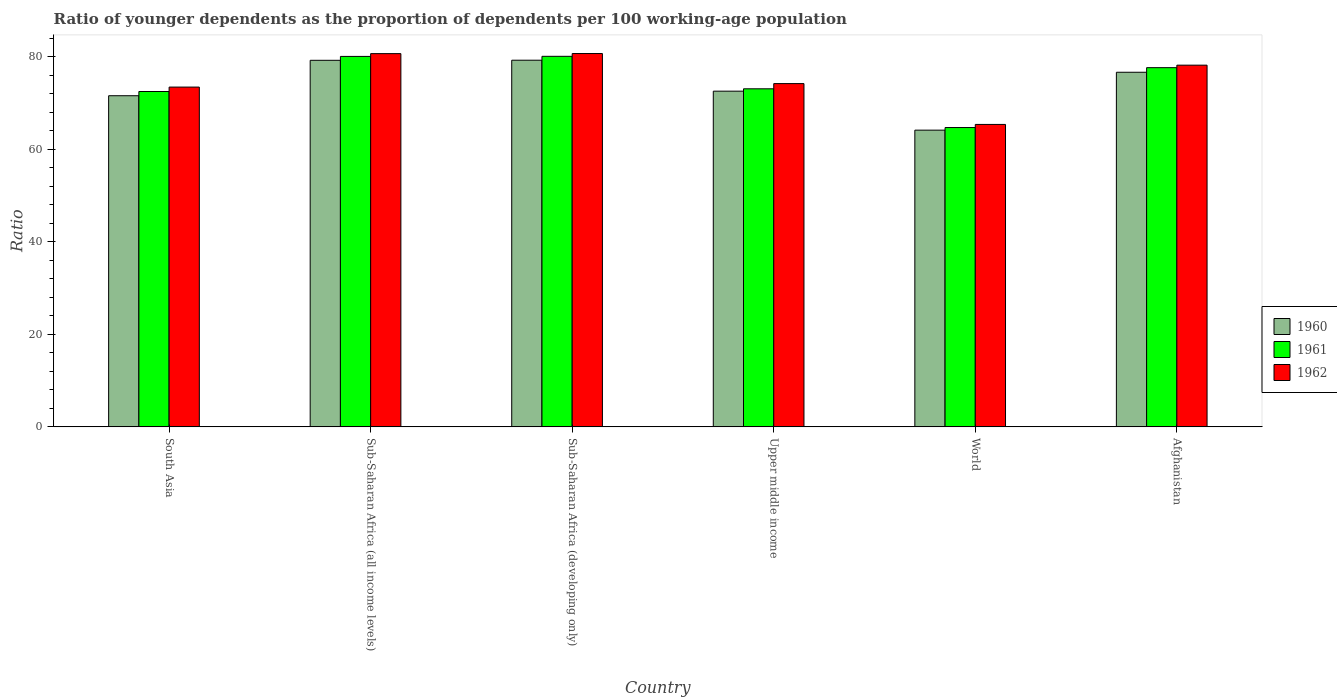How many different coloured bars are there?
Give a very brief answer. 3. Are the number of bars per tick equal to the number of legend labels?
Offer a terse response. Yes. How many bars are there on the 5th tick from the right?
Your answer should be very brief. 3. What is the age dependency ratio(young) in 1961 in Sub-Saharan Africa (all income levels)?
Your response must be concise. 80.06. Across all countries, what is the maximum age dependency ratio(young) in 1962?
Provide a succinct answer. 80.68. Across all countries, what is the minimum age dependency ratio(young) in 1962?
Your response must be concise. 65.36. In which country was the age dependency ratio(young) in 1962 maximum?
Keep it short and to the point. Sub-Saharan Africa (developing only). In which country was the age dependency ratio(young) in 1962 minimum?
Your answer should be compact. World. What is the total age dependency ratio(young) in 1961 in the graph?
Provide a short and direct response. 447.96. What is the difference between the age dependency ratio(young) in 1961 in Afghanistan and that in Upper middle income?
Ensure brevity in your answer.  4.57. What is the difference between the age dependency ratio(young) in 1961 in South Asia and the age dependency ratio(young) in 1962 in Sub-Saharan Africa (developing only)?
Make the answer very short. -8.21. What is the average age dependency ratio(young) in 1962 per country?
Offer a terse response. 75.41. What is the difference between the age dependency ratio(young) of/in 1961 and age dependency ratio(young) of/in 1960 in Upper middle income?
Keep it short and to the point. 0.51. In how many countries, is the age dependency ratio(young) in 1960 greater than 36?
Offer a terse response. 6. What is the ratio of the age dependency ratio(young) in 1961 in Afghanistan to that in Upper middle income?
Keep it short and to the point. 1.06. What is the difference between the highest and the second highest age dependency ratio(young) in 1960?
Give a very brief answer. -2.58. What is the difference between the highest and the lowest age dependency ratio(young) in 1961?
Provide a short and direct response. 15.39. In how many countries, is the age dependency ratio(young) in 1960 greater than the average age dependency ratio(young) in 1960 taken over all countries?
Your response must be concise. 3. Is the sum of the age dependency ratio(young) in 1962 in Sub-Saharan Africa (all income levels) and Sub-Saharan Africa (developing only) greater than the maximum age dependency ratio(young) in 1960 across all countries?
Provide a succinct answer. Yes. Is it the case that in every country, the sum of the age dependency ratio(young) in 1960 and age dependency ratio(young) in 1961 is greater than the age dependency ratio(young) in 1962?
Keep it short and to the point. Yes. Does the graph contain any zero values?
Provide a succinct answer. No. Where does the legend appear in the graph?
Provide a short and direct response. Center right. How are the legend labels stacked?
Give a very brief answer. Vertical. What is the title of the graph?
Give a very brief answer. Ratio of younger dependents as the proportion of dependents per 100 working-age population. What is the label or title of the Y-axis?
Your answer should be very brief. Ratio. What is the Ratio in 1960 in South Asia?
Offer a terse response. 71.56. What is the Ratio in 1961 in South Asia?
Your answer should be compact. 72.47. What is the Ratio of 1962 in South Asia?
Provide a succinct answer. 73.43. What is the Ratio in 1960 in Sub-Saharan Africa (all income levels)?
Provide a succinct answer. 79.21. What is the Ratio of 1961 in Sub-Saharan Africa (all income levels)?
Your answer should be compact. 80.06. What is the Ratio in 1962 in Sub-Saharan Africa (all income levels)?
Give a very brief answer. 80.66. What is the Ratio of 1960 in Sub-Saharan Africa (developing only)?
Your response must be concise. 79.23. What is the Ratio of 1961 in Sub-Saharan Africa (developing only)?
Offer a terse response. 80.07. What is the Ratio of 1962 in Sub-Saharan Africa (developing only)?
Ensure brevity in your answer.  80.68. What is the Ratio of 1960 in Upper middle income?
Your answer should be very brief. 72.54. What is the Ratio of 1961 in Upper middle income?
Offer a very short reply. 73.05. What is the Ratio of 1962 in Upper middle income?
Your answer should be very brief. 74.18. What is the Ratio of 1960 in World?
Your response must be concise. 64.12. What is the Ratio in 1961 in World?
Offer a terse response. 64.68. What is the Ratio in 1962 in World?
Offer a very short reply. 65.36. What is the Ratio in 1960 in Afghanistan?
Give a very brief answer. 76.63. What is the Ratio of 1961 in Afghanistan?
Make the answer very short. 77.62. What is the Ratio of 1962 in Afghanistan?
Keep it short and to the point. 78.17. Across all countries, what is the maximum Ratio in 1960?
Provide a short and direct response. 79.23. Across all countries, what is the maximum Ratio in 1961?
Give a very brief answer. 80.07. Across all countries, what is the maximum Ratio of 1962?
Your answer should be very brief. 80.68. Across all countries, what is the minimum Ratio in 1960?
Ensure brevity in your answer.  64.12. Across all countries, what is the minimum Ratio of 1961?
Your response must be concise. 64.68. Across all countries, what is the minimum Ratio of 1962?
Make the answer very short. 65.36. What is the total Ratio in 1960 in the graph?
Your response must be concise. 443.3. What is the total Ratio of 1961 in the graph?
Provide a succinct answer. 447.96. What is the total Ratio of 1962 in the graph?
Your answer should be compact. 452.46. What is the difference between the Ratio of 1960 in South Asia and that in Sub-Saharan Africa (all income levels)?
Your answer should be very brief. -7.65. What is the difference between the Ratio in 1961 in South Asia and that in Sub-Saharan Africa (all income levels)?
Offer a very short reply. -7.59. What is the difference between the Ratio in 1962 in South Asia and that in Sub-Saharan Africa (all income levels)?
Offer a terse response. -7.23. What is the difference between the Ratio of 1960 in South Asia and that in Sub-Saharan Africa (developing only)?
Offer a very short reply. -7.67. What is the difference between the Ratio in 1961 in South Asia and that in Sub-Saharan Africa (developing only)?
Your answer should be very brief. -7.6. What is the difference between the Ratio of 1962 in South Asia and that in Sub-Saharan Africa (developing only)?
Offer a terse response. -7.25. What is the difference between the Ratio in 1960 in South Asia and that in Upper middle income?
Offer a terse response. -0.99. What is the difference between the Ratio in 1961 in South Asia and that in Upper middle income?
Provide a short and direct response. -0.58. What is the difference between the Ratio in 1962 in South Asia and that in Upper middle income?
Offer a terse response. -0.76. What is the difference between the Ratio of 1960 in South Asia and that in World?
Make the answer very short. 7.44. What is the difference between the Ratio in 1961 in South Asia and that in World?
Provide a short and direct response. 7.79. What is the difference between the Ratio in 1962 in South Asia and that in World?
Offer a very short reply. 8.07. What is the difference between the Ratio of 1960 in South Asia and that in Afghanistan?
Your response must be concise. -5.07. What is the difference between the Ratio of 1961 in South Asia and that in Afghanistan?
Your answer should be compact. -5.15. What is the difference between the Ratio in 1962 in South Asia and that in Afghanistan?
Your answer should be very brief. -4.74. What is the difference between the Ratio of 1960 in Sub-Saharan Africa (all income levels) and that in Sub-Saharan Africa (developing only)?
Make the answer very short. -0.02. What is the difference between the Ratio in 1961 in Sub-Saharan Africa (all income levels) and that in Sub-Saharan Africa (developing only)?
Your response must be concise. -0.02. What is the difference between the Ratio of 1962 in Sub-Saharan Africa (all income levels) and that in Sub-Saharan Africa (developing only)?
Provide a short and direct response. -0.02. What is the difference between the Ratio of 1960 in Sub-Saharan Africa (all income levels) and that in Upper middle income?
Your answer should be compact. 6.67. What is the difference between the Ratio of 1961 in Sub-Saharan Africa (all income levels) and that in Upper middle income?
Your response must be concise. 7. What is the difference between the Ratio in 1962 in Sub-Saharan Africa (all income levels) and that in Upper middle income?
Your answer should be very brief. 6.48. What is the difference between the Ratio of 1960 in Sub-Saharan Africa (all income levels) and that in World?
Offer a very short reply. 15.09. What is the difference between the Ratio of 1961 in Sub-Saharan Africa (all income levels) and that in World?
Make the answer very short. 15.37. What is the difference between the Ratio in 1962 in Sub-Saharan Africa (all income levels) and that in World?
Provide a short and direct response. 15.3. What is the difference between the Ratio of 1960 in Sub-Saharan Africa (all income levels) and that in Afghanistan?
Provide a succinct answer. 2.58. What is the difference between the Ratio in 1961 in Sub-Saharan Africa (all income levels) and that in Afghanistan?
Offer a very short reply. 2.43. What is the difference between the Ratio in 1962 in Sub-Saharan Africa (all income levels) and that in Afghanistan?
Offer a very short reply. 2.49. What is the difference between the Ratio of 1960 in Sub-Saharan Africa (developing only) and that in Upper middle income?
Keep it short and to the point. 6.69. What is the difference between the Ratio of 1961 in Sub-Saharan Africa (developing only) and that in Upper middle income?
Your answer should be compact. 7.02. What is the difference between the Ratio of 1962 in Sub-Saharan Africa (developing only) and that in Upper middle income?
Give a very brief answer. 6.49. What is the difference between the Ratio in 1960 in Sub-Saharan Africa (developing only) and that in World?
Your answer should be very brief. 15.11. What is the difference between the Ratio of 1961 in Sub-Saharan Africa (developing only) and that in World?
Your answer should be very brief. 15.39. What is the difference between the Ratio of 1962 in Sub-Saharan Africa (developing only) and that in World?
Keep it short and to the point. 15.32. What is the difference between the Ratio of 1960 in Sub-Saharan Africa (developing only) and that in Afghanistan?
Offer a terse response. 2.6. What is the difference between the Ratio in 1961 in Sub-Saharan Africa (developing only) and that in Afghanistan?
Provide a short and direct response. 2.45. What is the difference between the Ratio in 1962 in Sub-Saharan Africa (developing only) and that in Afghanistan?
Provide a succinct answer. 2.51. What is the difference between the Ratio in 1960 in Upper middle income and that in World?
Ensure brevity in your answer.  8.42. What is the difference between the Ratio in 1961 in Upper middle income and that in World?
Give a very brief answer. 8.37. What is the difference between the Ratio in 1962 in Upper middle income and that in World?
Offer a very short reply. 8.82. What is the difference between the Ratio in 1960 in Upper middle income and that in Afghanistan?
Make the answer very short. -4.09. What is the difference between the Ratio in 1961 in Upper middle income and that in Afghanistan?
Provide a succinct answer. -4.57. What is the difference between the Ratio in 1962 in Upper middle income and that in Afghanistan?
Provide a short and direct response. -3.98. What is the difference between the Ratio in 1960 in World and that in Afghanistan?
Your response must be concise. -12.51. What is the difference between the Ratio of 1961 in World and that in Afghanistan?
Offer a very short reply. -12.94. What is the difference between the Ratio in 1962 in World and that in Afghanistan?
Ensure brevity in your answer.  -12.81. What is the difference between the Ratio of 1960 in South Asia and the Ratio of 1961 in Sub-Saharan Africa (all income levels)?
Your response must be concise. -8.5. What is the difference between the Ratio in 1960 in South Asia and the Ratio in 1962 in Sub-Saharan Africa (all income levels)?
Ensure brevity in your answer.  -9.1. What is the difference between the Ratio of 1961 in South Asia and the Ratio of 1962 in Sub-Saharan Africa (all income levels)?
Give a very brief answer. -8.19. What is the difference between the Ratio of 1960 in South Asia and the Ratio of 1961 in Sub-Saharan Africa (developing only)?
Give a very brief answer. -8.52. What is the difference between the Ratio of 1960 in South Asia and the Ratio of 1962 in Sub-Saharan Africa (developing only)?
Provide a succinct answer. -9.12. What is the difference between the Ratio of 1961 in South Asia and the Ratio of 1962 in Sub-Saharan Africa (developing only)?
Give a very brief answer. -8.21. What is the difference between the Ratio in 1960 in South Asia and the Ratio in 1961 in Upper middle income?
Ensure brevity in your answer.  -1.49. What is the difference between the Ratio in 1960 in South Asia and the Ratio in 1962 in Upper middle income?
Your answer should be compact. -2.62. What is the difference between the Ratio of 1961 in South Asia and the Ratio of 1962 in Upper middle income?
Give a very brief answer. -1.71. What is the difference between the Ratio of 1960 in South Asia and the Ratio of 1961 in World?
Make the answer very short. 6.88. What is the difference between the Ratio in 1960 in South Asia and the Ratio in 1962 in World?
Give a very brief answer. 6.2. What is the difference between the Ratio in 1961 in South Asia and the Ratio in 1962 in World?
Your answer should be very brief. 7.11. What is the difference between the Ratio in 1960 in South Asia and the Ratio in 1961 in Afghanistan?
Your response must be concise. -6.06. What is the difference between the Ratio in 1960 in South Asia and the Ratio in 1962 in Afghanistan?
Your answer should be compact. -6.61. What is the difference between the Ratio of 1961 in South Asia and the Ratio of 1962 in Afghanistan?
Your answer should be very brief. -5.69. What is the difference between the Ratio of 1960 in Sub-Saharan Africa (all income levels) and the Ratio of 1961 in Sub-Saharan Africa (developing only)?
Provide a succinct answer. -0.86. What is the difference between the Ratio of 1960 in Sub-Saharan Africa (all income levels) and the Ratio of 1962 in Sub-Saharan Africa (developing only)?
Provide a succinct answer. -1.46. What is the difference between the Ratio of 1961 in Sub-Saharan Africa (all income levels) and the Ratio of 1962 in Sub-Saharan Africa (developing only)?
Offer a terse response. -0.62. What is the difference between the Ratio of 1960 in Sub-Saharan Africa (all income levels) and the Ratio of 1961 in Upper middle income?
Offer a very short reply. 6.16. What is the difference between the Ratio in 1960 in Sub-Saharan Africa (all income levels) and the Ratio in 1962 in Upper middle income?
Your response must be concise. 5.03. What is the difference between the Ratio of 1961 in Sub-Saharan Africa (all income levels) and the Ratio of 1962 in Upper middle income?
Keep it short and to the point. 5.87. What is the difference between the Ratio of 1960 in Sub-Saharan Africa (all income levels) and the Ratio of 1961 in World?
Make the answer very short. 14.53. What is the difference between the Ratio in 1960 in Sub-Saharan Africa (all income levels) and the Ratio in 1962 in World?
Provide a short and direct response. 13.86. What is the difference between the Ratio in 1961 in Sub-Saharan Africa (all income levels) and the Ratio in 1962 in World?
Provide a short and direct response. 14.7. What is the difference between the Ratio in 1960 in Sub-Saharan Africa (all income levels) and the Ratio in 1961 in Afghanistan?
Keep it short and to the point. 1.59. What is the difference between the Ratio of 1960 in Sub-Saharan Africa (all income levels) and the Ratio of 1962 in Afghanistan?
Your answer should be very brief. 1.05. What is the difference between the Ratio of 1961 in Sub-Saharan Africa (all income levels) and the Ratio of 1962 in Afghanistan?
Make the answer very short. 1.89. What is the difference between the Ratio of 1960 in Sub-Saharan Africa (developing only) and the Ratio of 1961 in Upper middle income?
Your answer should be compact. 6.18. What is the difference between the Ratio in 1960 in Sub-Saharan Africa (developing only) and the Ratio in 1962 in Upper middle income?
Your answer should be compact. 5.05. What is the difference between the Ratio of 1961 in Sub-Saharan Africa (developing only) and the Ratio of 1962 in Upper middle income?
Provide a succinct answer. 5.89. What is the difference between the Ratio in 1960 in Sub-Saharan Africa (developing only) and the Ratio in 1961 in World?
Your response must be concise. 14.55. What is the difference between the Ratio in 1960 in Sub-Saharan Africa (developing only) and the Ratio in 1962 in World?
Provide a succinct answer. 13.88. What is the difference between the Ratio of 1961 in Sub-Saharan Africa (developing only) and the Ratio of 1962 in World?
Offer a terse response. 14.72. What is the difference between the Ratio of 1960 in Sub-Saharan Africa (developing only) and the Ratio of 1961 in Afghanistan?
Your response must be concise. 1.61. What is the difference between the Ratio of 1960 in Sub-Saharan Africa (developing only) and the Ratio of 1962 in Afghanistan?
Your answer should be compact. 1.07. What is the difference between the Ratio in 1961 in Sub-Saharan Africa (developing only) and the Ratio in 1962 in Afghanistan?
Give a very brief answer. 1.91. What is the difference between the Ratio in 1960 in Upper middle income and the Ratio in 1961 in World?
Provide a short and direct response. 7.86. What is the difference between the Ratio in 1960 in Upper middle income and the Ratio in 1962 in World?
Provide a succinct answer. 7.19. What is the difference between the Ratio in 1961 in Upper middle income and the Ratio in 1962 in World?
Keep it short and to the point. 7.7. What is the difference between the Ratio in 1960 in Upper middle income and the Ratio in 1961 in Afghanistan?
Your answer should be very brief. -5.08. What is the difference between the Ratio in 1960 in Upper middle income and the Ratio in 1962 in Afghanistan?
Provide a short and direct response. -5.62. What is the difference between the Ratio in 1961 in Upper middle income and the Ratio in 1962 in Afghanistan?
Keep it short and to the point. -5.11. What is the difference between the Ratio in 1960 in World and the Ratio in 1961 in Afghanistan?
Provide a short and direct response. -13.5. What is the difference between the Ratio of 1960 in World and the Ratio of 1962 in Afghanistan?
Offer a terse response. -14.04. What is the difference between the Ratio in 1961 in World and the Ratio in 1962 in Afghanistan?
Provide a short and direct response. -13.48. What is the average Ratio of 1960 per country?
Provide a short and direct response. 73.88. What is the average Ratio of 1961 per country?
Ensure brevity in your answer.  74.66. What is the average Ratio of 1962 per country?
Your response must be concise. 75.41. What is the difference between the Ratio in 1960 and Ratio in 1961 in South Asia?
Provide a succinct answer. -0.91. What is the difference between the Ratio of 1960 and Ratio of 1962 in South Asia?
Make the answer very short. -1.87. What is the difference between the Ratio of 1961 and Ratio of 1962 in South Asia?
Provide a short and direct response. -0.96. What is the difference between the Ratio in 1960 and Ratio in 1961 in Sub-Saharan Africa (all income levels)?
Offer a terse response. -0.84. What is the difference between the Ratio in 1960 and Ratio in 1962 in Sub-Saharan Africa (all income levels)?
Give a very brief answer. -1.44. What is the difference between the Ratio in 1961 and Ratio in 1962 in Sub-Saharan Africa (all income levels)?
Give a very brief answer. -0.6. What is the difference between the Ratio of 1960 and Ratio of 1961 in Sub-Saharan Africa (developing only)?
Your response must be concise. -0.84. What is the difference between the Ratio in 1960 and Ratio in 1962 in Sub-Saharan Africa (developing only)?
Make the answer very short. -1.44. What is the difference between the Ratio in 1961 and Ratio in 1962 in Sub-Saharan Africa (developing only)?
Offer a terse response. -0.6. What is the difference between the Ratio of 1960 and Ratio of 1961 in Upper middle income?
Give a very brief answer. -0.51. What is the difference between the Ratio of 1960 and Ratio of 1962 in Upper middle income?
Offer a terse response. -1.64. What is the difference between the Ratio in 1961 and Ratio in 1962 in Upper middle income?
Provide a short and direct response. -1.13. What is the difference between the Ratio in 1960 and Ratio in 1961 in World?
Make the answer very short. -0.56. What is the difference between the Ratio in 1960 and Ratio in 1962 in World?
Provide a short and direct response. -1.24. What is the difference between the Ratio of 1961 and Ratio of 1962 in World?
Your answer should be compact. -0.67. What is the difference between the Ratio in 1960 and Ratio in 1961 in Afghanistan?
Provide a succinct answer. -0.99. What is the difference between the Ratio of 1960 and Ratio of 1962 in Afghanistan?
Make the answer very short. -1.53. What is the difference between the Ratio in 1961 and Ratio in 1962 in Afghanistan?
Your answer should be very brief. -0.54. What is the ratio of the Ratio in 1960 in South Asia to that in Sub-Saharan Africa (all income levels)?
Your answer should be compact. 0.9. What is the ratio of the Ratio in 1961 in South Asia to that in Sub-Saharan Africa (all income levels)?
Ensure brevity in your answer.  0.91. What is the ratio of the Ratio in 1962 in South Asia to that in Sub-Saharan Africa (all income levels)?
Offer a terse response. 0.91. What is the ratio of the Ratio in 1960 in South Asia to that in Sub-Saharan Africa (developing only)?
Offer a terse response. 0.9. What is the ratio of the Ratio in 1961 in South Asia to that in Sub-Saharan Africa (developing only)?
Make the answer very short. 0.91. What is the ratio of the Ratio in 1962 in South Asia to that in Sub-Saharan Africa (developing only)?
Give a very brief answer. 0.91. What is the ratio of the Ratio of 1960 in South Asia to that in Upper middle income?
Give a very brief answer. 0.99. What is the ratio of the Ratio in 1961 in South Asia to that in Upper middle income?
Offer a very short reply. 0.99. What is the ratio of the Ratio of 1962 in South Asia to that in Upper middle income?
Your response must be concise. 0.99. What is the ratio of the Ratio in 1960 in South Asia to that in World?
Provide a succinct answer. 1.12. What is the ratio of the Ratio of 1961 in South Asia to that in World?
Make the answer very short. 1.12. What is the ratio of the Ratio in 1962 in South Asia to that in World?
Provide a short and direct response. 1.12. What is the ratio of the Ratio of 1960 in South Asia to that in Afghanistan?
Your response must be concise. 0.93. What is the ratio of the Ratio of 1961 in South Asia to that in Afghanistan?
Offer a very short reply. 0.93. What is the ratio of the Ratio in 1962 in South Asia to that in Afghanistan?
Ensure brevity in your answer.  0.94. What is the ratio of the Ratio in 1960 in Sub-Saharan Africa (all income levels) to that in Sub-Saharan Africa (developing only)?
Provide a succinct answer. 1. What is the ratio of the Ratio in 1962 in Sub-Saharan Africa (all income levels) to that in Sub-Saharan Africa (developing only)?
Provide a short and direct response. 1. What is the ratio of the Ratio in 1960 in Sub-Saharan Africa (all income levels) to that in Upper middle income?
Offer a terse response. 1.09. What is the ratio of the Ratio in 1961 in Sub-Saharan Africa (all income levels) to that in Upper middle income?
Offer a very short reply. 1.1. What is the ratio of the Ratio of 1962 in Sub-Saharan Africa (all income levels) to that in Upper middle income?
Make the answer very short. 1.09. What is the ratio of the Ratio of 1960 in Sub-Saharan Africa (all income levels) to that in World?
Your answer should be very brief. 1.24. What is the ratio of the Ratio of 1961 in Sub-Saharan Africa (all income levels) to that in World?
Provide a succinct answer. 1.24. What is the ratio of the Ratio of 1962 in Sub-Saharan Africa (all income levels) to that in World?
Keep it short and to the point. 1.23. What is the ratio of the Ratio in 1960 in Sub-Saharan Africa (all income levels) to that in Afghanistan?
Your response must be concise. 1.03. What is the ratio of the Ratio of 1961 in Sub-Saharan Africa (all income levels) to that in Afghanistan?
Provide a succinct answer. 1.03. What is the ratio of the Ratio of 1962 in Sub-Saharan Africa (all income levels) to that in Afghanistan?
Your response must be concise. 1.03. What is the ratio of the Ratio in 1960 in Sub-Saharan Africa (developing only) to that in Upper middle income?
Offer a terse response. 1.09. What is the ratio of the Ratio of 1961 in Sub-Saharan Africa (developing only) to that in Upper middle income?
Ensure brevity in your answer.  1.1. What is the ratio of the Ratio in 1962 in Sub-Saharan Africa (developing only) to that in Upper middle income?
Give a very brief answer. 1.09. What is the ratio of the Ratio of 1960 in Sub-Saharan Africa (developing only) to that in World?
Offer a very short reply. 1.24. What is the ratio of the Ratio in 1961 in Sub-Saharan Africa (developing only) to that in World?
Your answer should be very brief. 1.24. What is the ratio of the Ratio of 1962 in Sub-Saharan Africa (developing only) to that in World?
Ensure brevity in your answer.  1.23. What is the ratio of the Ratio in 1960 in Sub-Saharan Africa (developing only) to that in Afghanistan?
Provide a short and direct response. 1.03. What is the ratio of the Ratio of 1961 in Sub-Saharan Africa (developing only) to that in Afghanistan?
Ensure brevity in your answer.  1.03. What is the ratio of the Ratio of 1962 in Sub-Saharan Africa (developing only) to that in Afghanistan?
Keep it short and to the point. 1.03. What is the ratio of the Ratio in 1960 in Upper middle income to that in World?
Ensure brevity in your answer.  1.13. What is the ratio of the Ratio in 1961 in Upper middle income to that in World?
Keep it short and to the point. 1.13. What is the ratio of the Ratio of 1962 in Upper middle income to that in World?
Provide a short and direct response. 1.14. What is the ratio of the Ratio of 1960 in Upper middle income to that in Afghanistan?
Your response must be concise. 0.95. What is the ratio of the Ratio in 1961 in Upper middle income to that in Afghanistan?
Give a very brief answer. 0.94. What is the ratio of the Ratio of 1962 in Upper middle income to that in Afghanistan?
Provide a succinct answer. 0.95. What is the ratio of the Ratio in 1960 in World to that in Afghanistan?
Your answer should be very brief. 0.84. What is the ratio of the Ratio of 1962 in World to that in Afghanistan?
Your response must be concise. 0.84. What is the difference between the highest and the second highest Ratio in 1960?
Ensure brevity in your answer.  0.02. What is the difference between the highest and the second highest Ratio of 1961?
Provide a succinct answer. 0.02. What is the difference between the highest and the second highest Ratio of 1962?
Offer a very short reply. 0.02. What is the difference between the highest and the lowest Ratio of 1960?
Offer a very short reply. 15.11. What is the difference between the highest and the lowest Ratio in 1961?
Ensure brevity in your answer.  15.39. What is the difference between the highest and the lowest Ratio of 1962?
Keep it short and to the point. 15.32. 